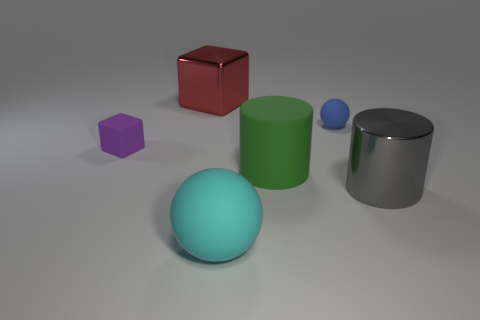Is there a gray cylinder that has the same size as the green thing?
Give a very brief answer. Yes. There is a cylinder left of the shiny object right of the red metallic block; what is its size?
Your answer should be compact. Large. Are there fewer big green rubber objects behind the big red metal object than small yellow metallic cylinders?
Ensure brevity in your answer.  No. Does the big sphere have the same color as the rubber block?
Make the answer very short. No. How big is the green object?
Your answer should be very brief. Large. How many big cylinders are the same color as the tiny matte ball?
Ensure brevity in your answer.  0. There is a large object behind the rubber ball behind the tiny rubber cube; is there a rubber sphere that is behind it?
Give a very brief answer. No. What is the shape of the red metallic object that is the same size as the green object?
Offer a terse response. Cube. What number of small objects are cyan matte cubes or green rubber things?
Provide a short and direct response. 0. What color is the large cylinder that is made of the same material as the red thing?
Keep it short and to the point. Gray. 